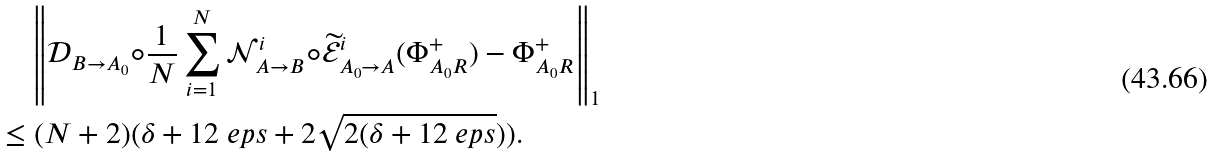Convert formula to latex. <formula><loc_0><loc_0><loc_500><loc_500>& \quad \left \| \mathcal { D } _ { B \to A _ { 0 } } \circ \frac { 1 } { N } \sum _ { i = 1 } ^ { N } \mathcal { N } ^ { i } _ { A \to B } \circ \widetilde { \mathcal { E } } ^ { i } _ { A _ { 0 } \to A } ( \Phi ^ { + } _ { A _ { 0 } R } ) - \Phi ^ { + } _ { A _ { 0 } R } \right \| _ { 1 } \\ & \leq ( N + 2 ) ( \delta + 1 2 \ e p s + 2 \sqrt { 2 ( \delta + 1 2 \ e p s } ) ) .</formula> 